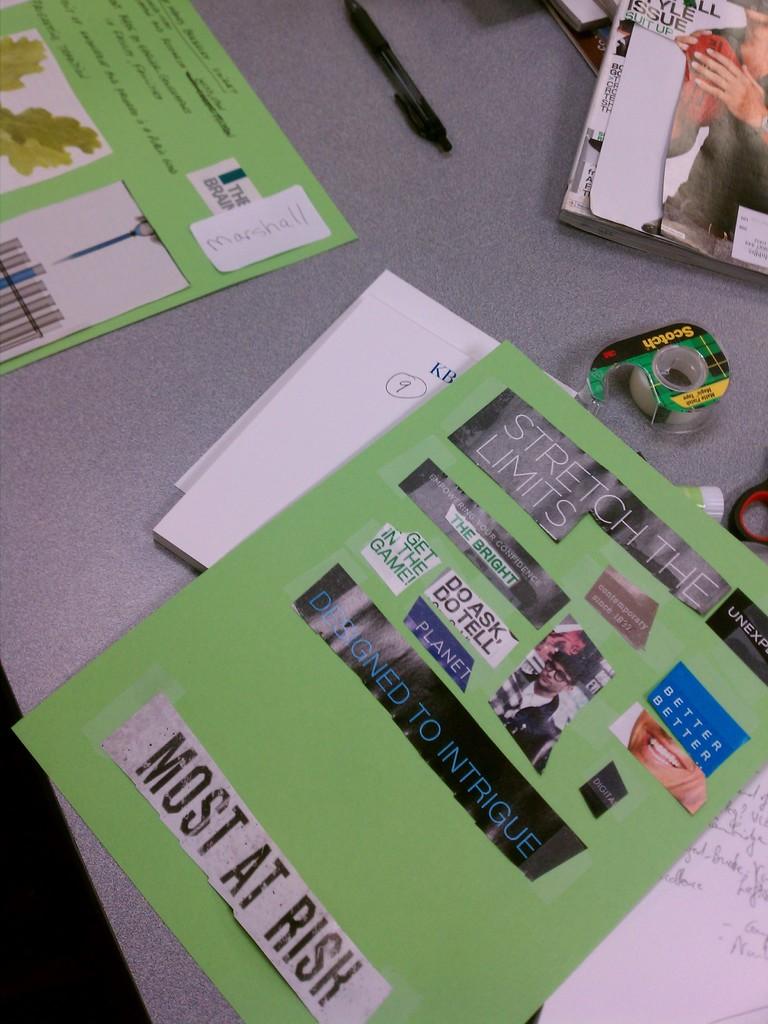What should be stretched?
Ensure brevity in your answer.  The limits. How many are at risk according to the paper?
Your response must be concise. Most. 